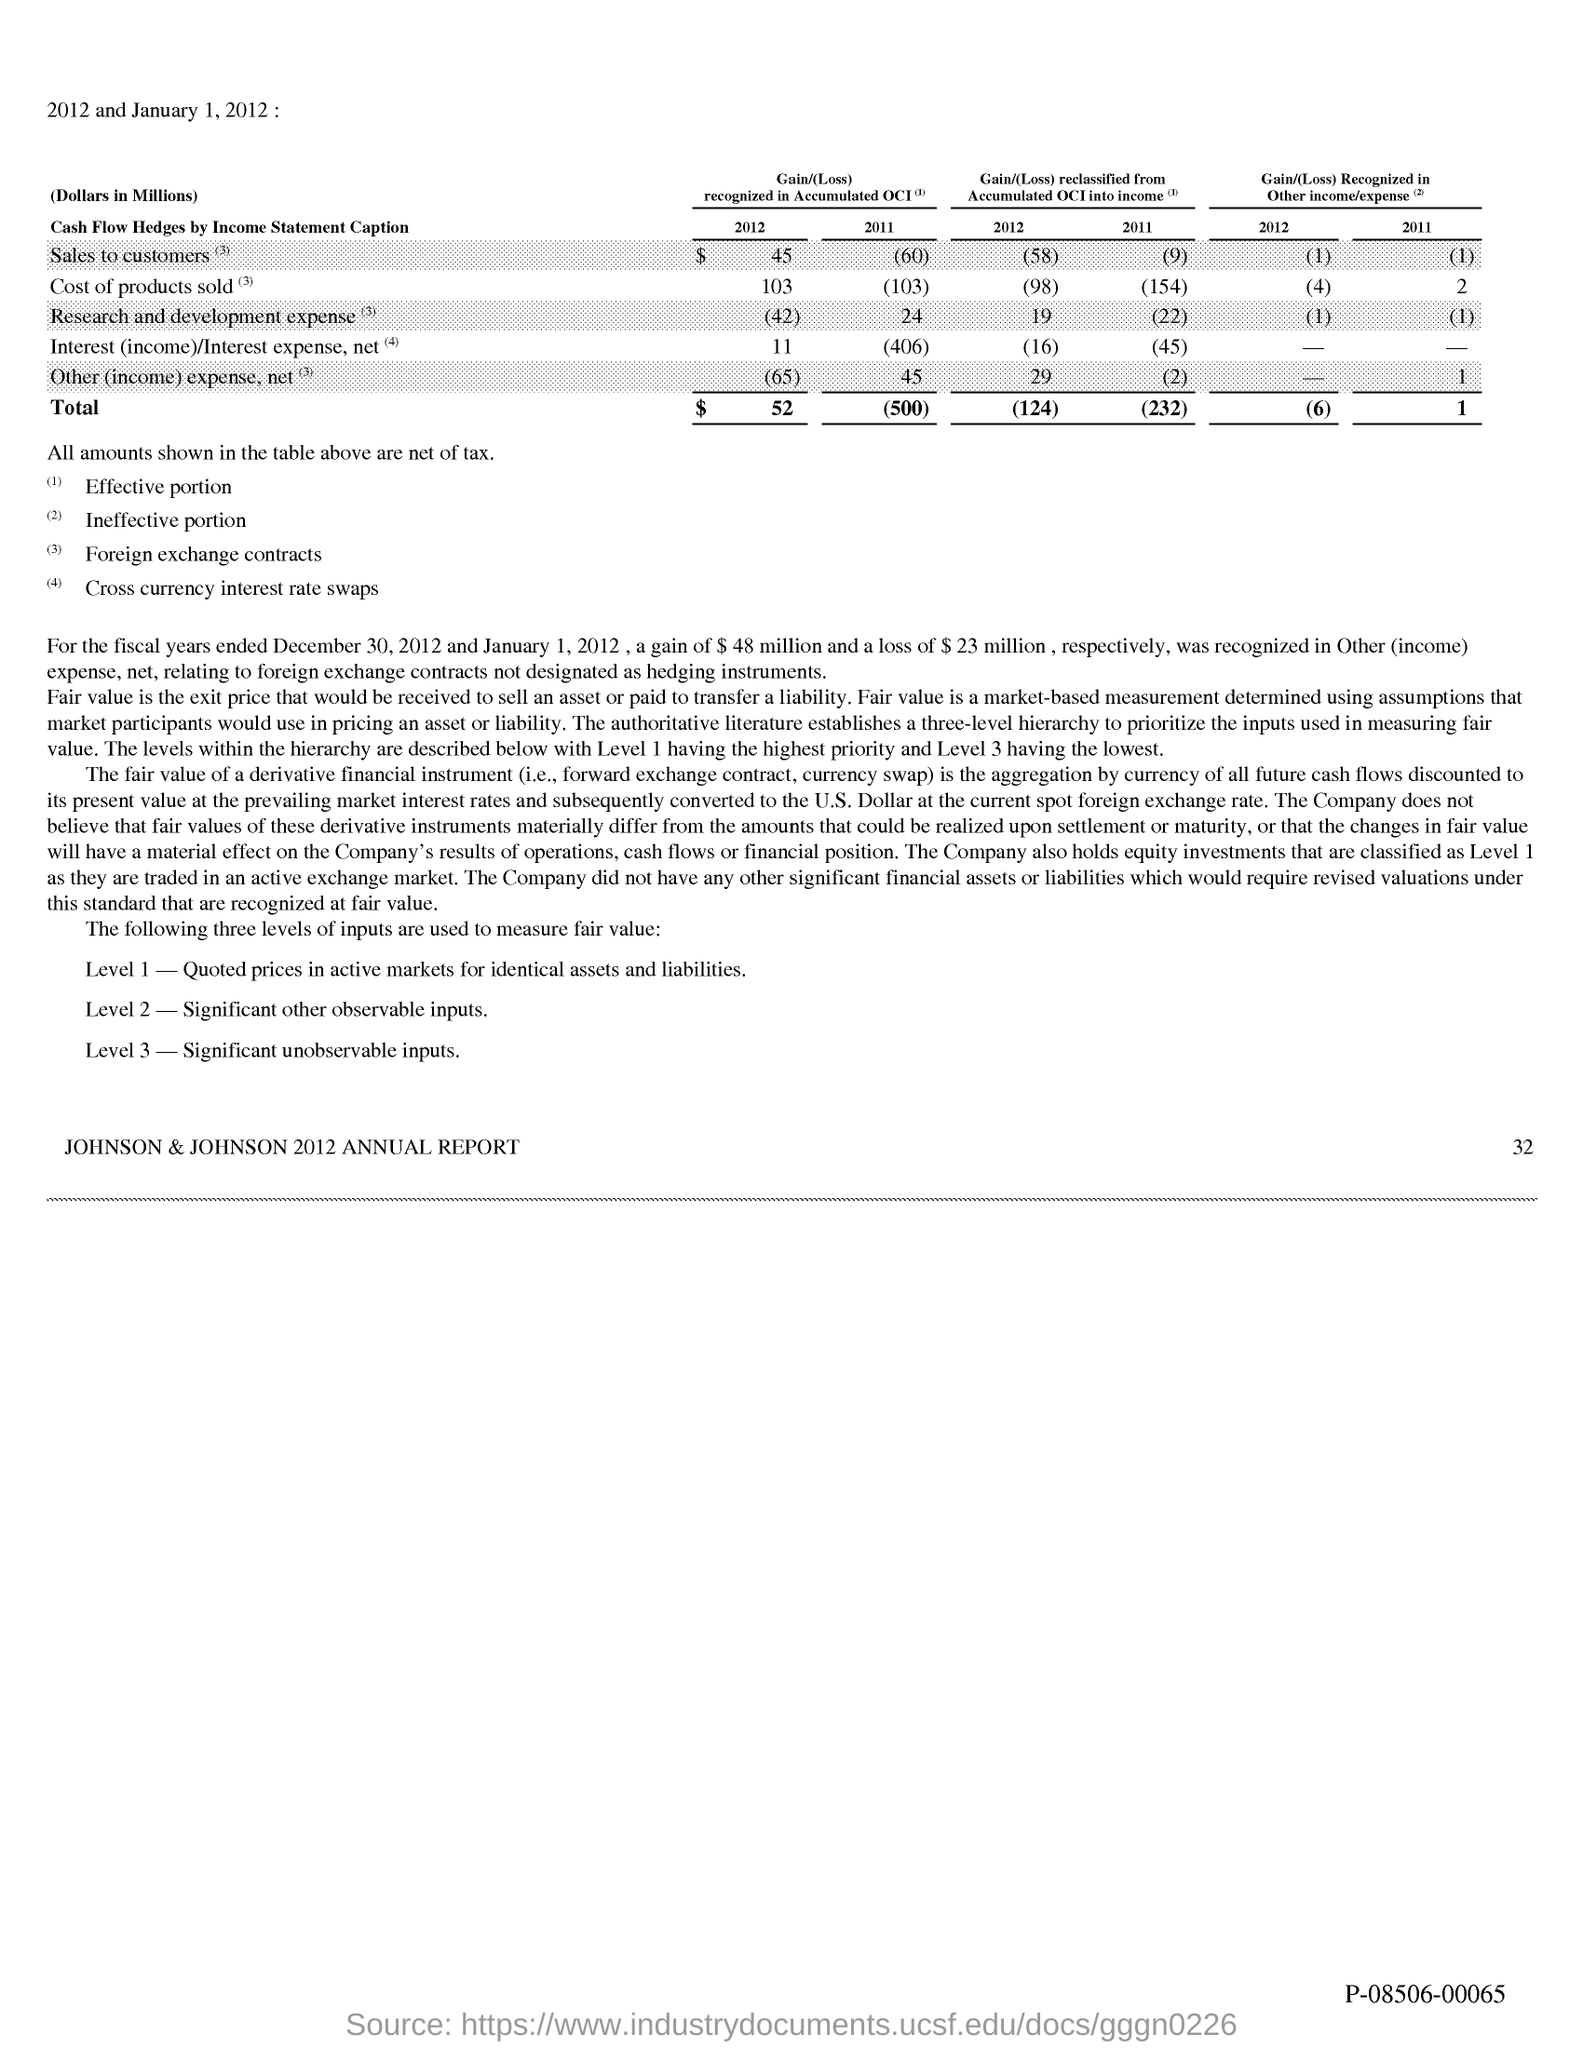Mention a couple of crucial points in this snapshot. The Level 3 inputs used to measure fair value involve significant unobservable inputs that are difficult to measure and are often based on management's assumptions and estimates. The company holds equity investments. The highest priority level is level 1. The Level 1 input for measuring fair value is the quoted prices in active markets for identical assets and liabilities. The Level 2 input used to measure fair value is significant other observable inputs. 